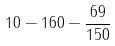<formula> <loc_0><loc_0><loc_500><loc_500>1 0 - 1 6 0 - \frac { 6 9 } { 1 5 0 }</formula> 